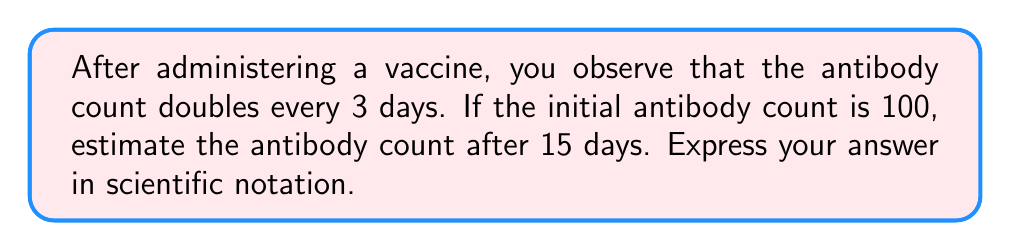Teach me how to tackle this problem. Let's approach this step-by-step:

1) First, we need to determine how many times the antibody count will double in 15 days:
   $\frac{15 \text{ days}}{3 \text{ days per doubling}} = 5 \text{ doublings}$

2) Now, we can express this as an exponential growth equation:
   $\text{Final count} = \text{Initial count} \times 2^{\text{number of doublings}}$

3) Plugging in our values:
   $\text{Final count} = 100 \times 2^5$

4) Let's calculate $2^5$:
   $2^5 = 2 \times 2 \times 2 \times 2 \times 2 = 32$

5) Now we can complete our calculation:
   $\text{Final count} = 100 \times 32 = 3200$

6) To express this in scientific notation, we move the decimal point 3 places to the left:
   $3200 = 3.2 \times 10^3$

Therefore, after 15 days, the estimated antibody count would be $3.2 \times 10^3$.
Answer: $3.2 \times 10^3$ 